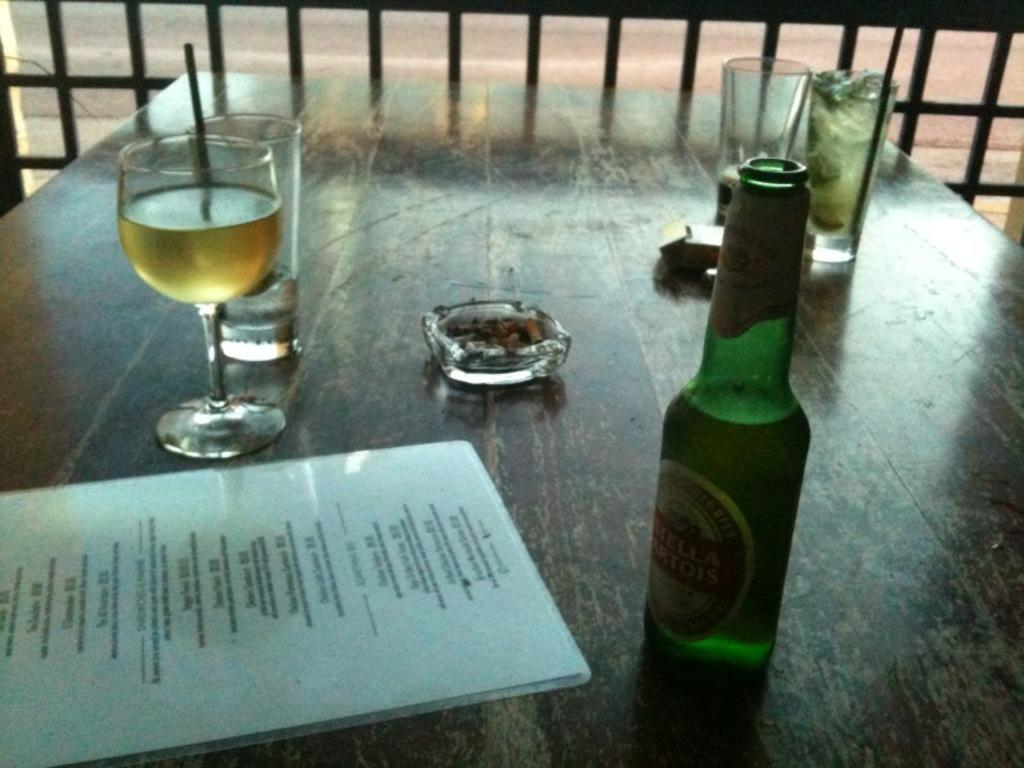What piece of furniture is present in the image? There is a table in the image. What is placed on the table? There is a glass with a drink, a bottle, a cigarette box, a tray, and a menu card on the table. What can be seen in the background of the image? There is a fence in the background of the image. What type of ornament is the kitty wearing in the image? There is no kitty present in the image, so it is not possible to determine if it is wearing an ornament or not. 